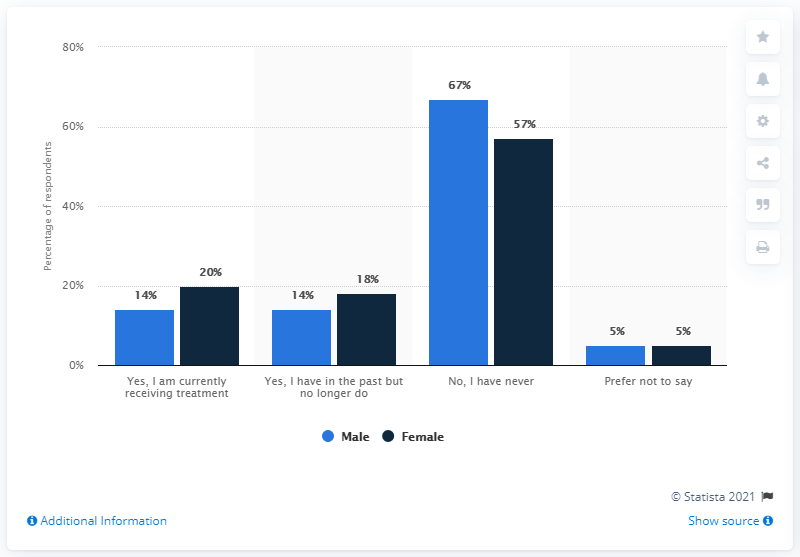Indicate a few pertinent items in this graphic. The mode of the green bar graph is 150. The average of 'No, I have never' is 62. 